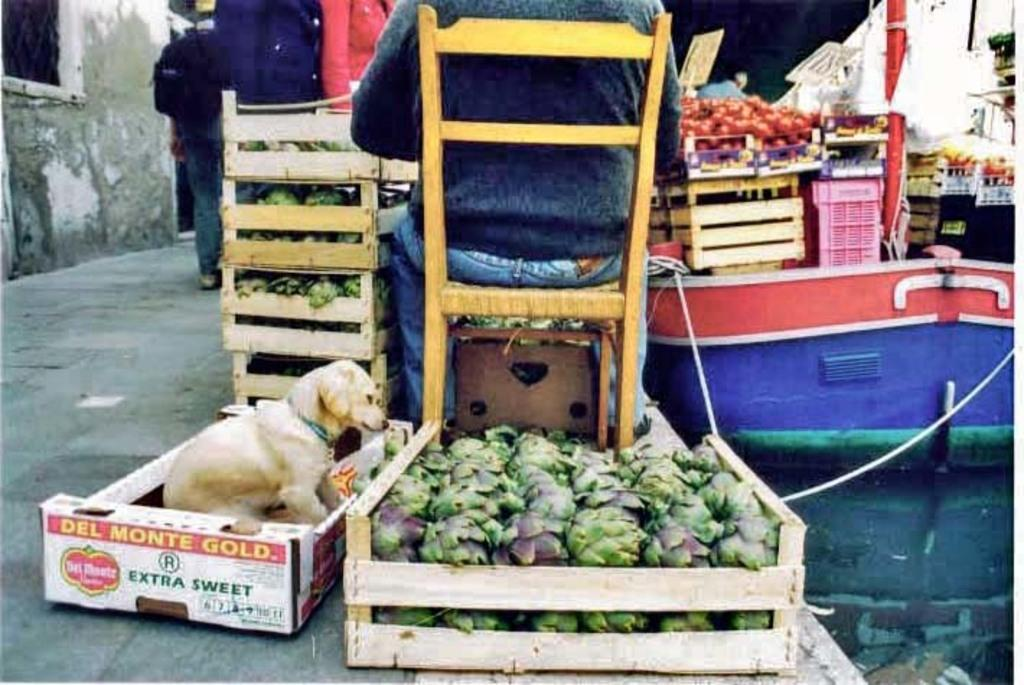What is inside the boxes that are visible in the image? There are many boxes containing vegetables in the image. Can you describe the animal that is on one of the boxes? There is a dog on one of the boxes in the image. What is the person in the image doing? A person is sitting on a chair in the image. What is located on the left side of the image? There is a wall on the left side of the image. How many judges are present in the image? There are no judges present in the image. What type of selection process is taking place in the image? There is no selection process depicted in the image; it features boxes of vegetables, a dog, a person sitting on a chair, and a wall. 